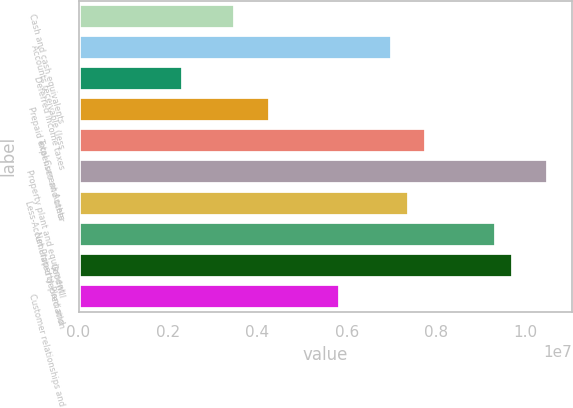<chart> <loc_0><loc_0><loc_500><loc_500><bar_chart><fcel>Cash and cash equivalents<fcel>Accounts receivable (less<fcel>Deferred income taxes<fcel>Prepaid expenses and other<fcel>Total Current Assets<fcel>Property plant and equipment<fcel>Less-Accumulated depreciation<fcel>Net Property Plant and<fcel>Goodwill<fcel>Customer relationships and<nl><fcel>3.50297e+06<fcel>7.00509e+06<fcel>2.3356e+06<fcel>4.28122e+06<fcel>7.78334e+06<fcel>1.05072e+07<fcel>7.39422e+06<fcel>9.33984e+06<fcel>9.72896e+06<fcel>5.83772e+06<nl></chart> 